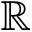Convert formula to latex. <formula><loc_0><loc_0><loc_500><loc_500>\mathbb { R }</formula> 